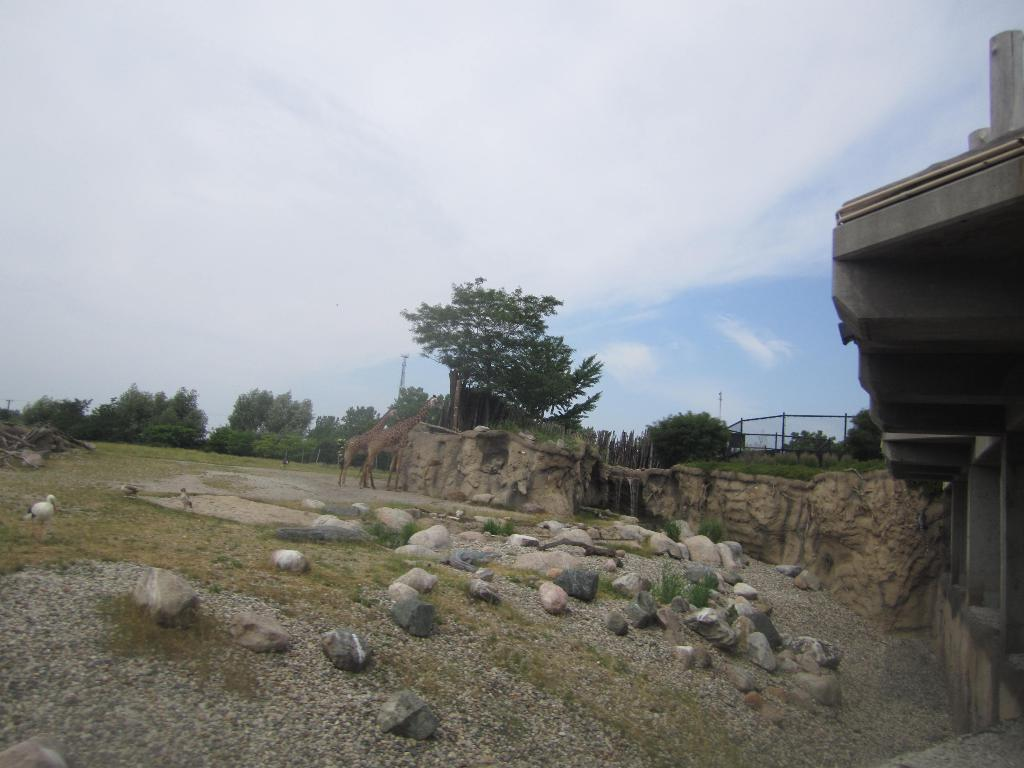What type of animals can be seen in the image? There are giraffes in the image. What type of vegetation is present in the image? There are trees in the image. What type of structure is visible in the image? There is a building in the image. What type of ground surface is visible in the image? There are stones on the ground in the image. What type of birds can be seen in the image? There are birds on the left side of the image. What is visible at the top of the image? The sky is visible at the top of the image. Where is the pin located in the image? There is no pin present in the image. What type of bear can be seen interacting with the giraffes in the image? There are no bears present in the image; only giraffes, trees, a building, stones, birds, and the sky are visible. 